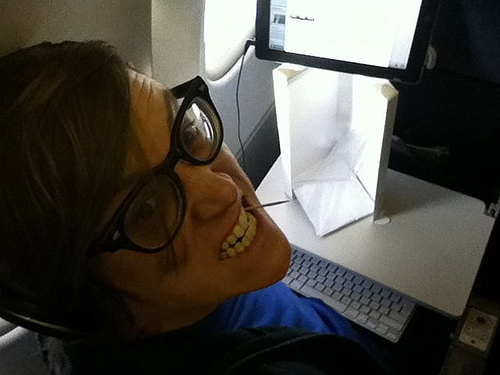What device is to the right of the guy? The device to the right of the guy is a screen, likely a tablet or a small monitor. 